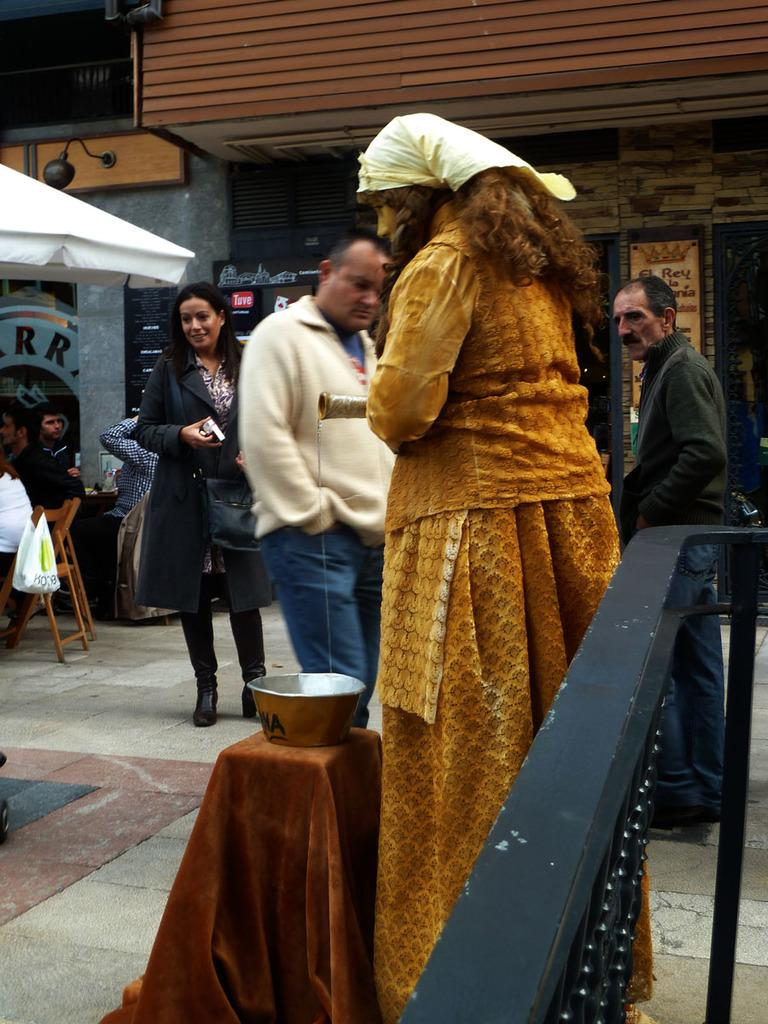Who or what is present in the image? There are people in the image. What are the people sitting on in the image? There are chairs in the image. What is on an object in the image? There is a bowl on an object in the image. What type of structure is visible in the image? There is a grille in the image. What can be seen in the distance in the image? There are buildings in the background of the image. What color is the horse in the image? There is no horse present in the image. Is the scene taking place during the night in the image? The image does not provide any information about the time of day, so it cannot be determined if it is night or not. 